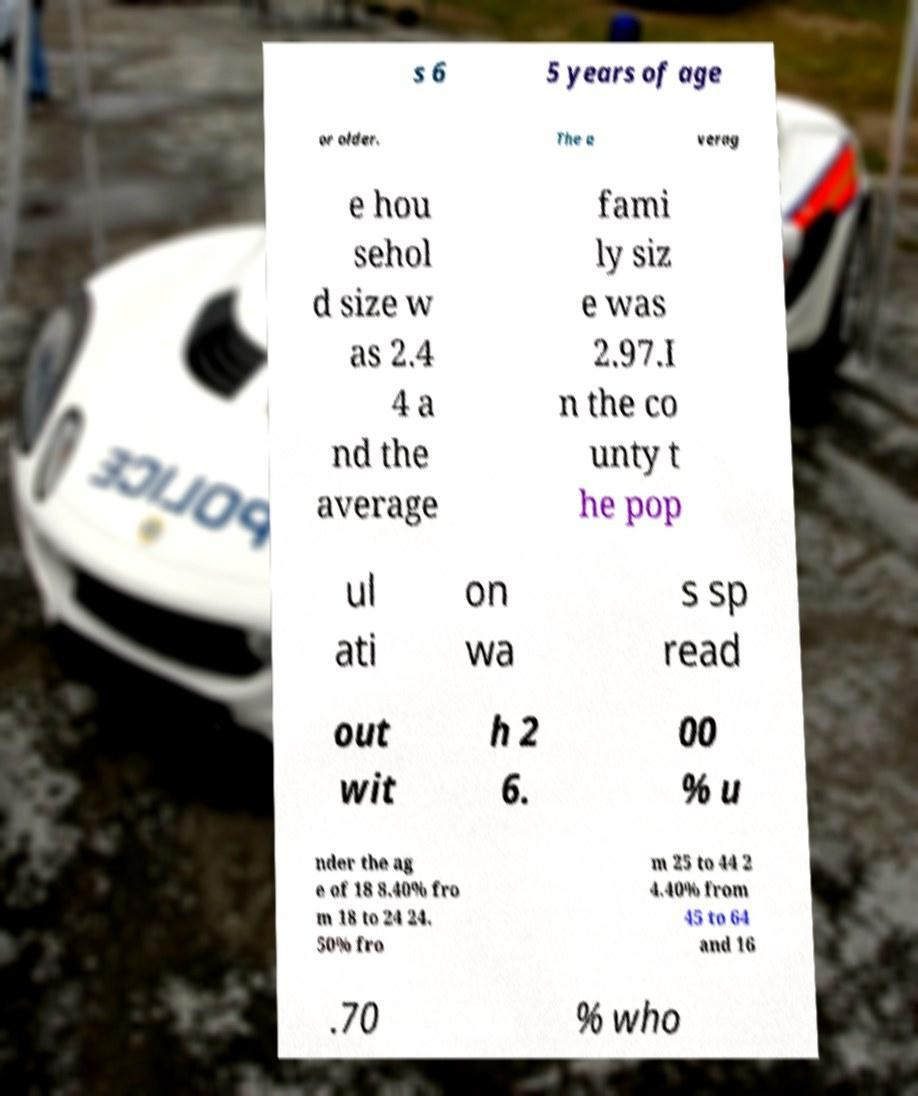Could you extract and type out the text from this image? s 6 5 years of age or older. The a verag e hou sehol d size w as 2.4 4 a nd the average fami ly siz e was 2.97.I n the co unty t he pop ul ati on wa s sp read out wit h 2 6. 00 % u nder the ag e of 18 8.40% fro m 18 to 24 24. 50% fro m 25 to 44 2 4.40% from 45 to 64 and 16 .70 % who 